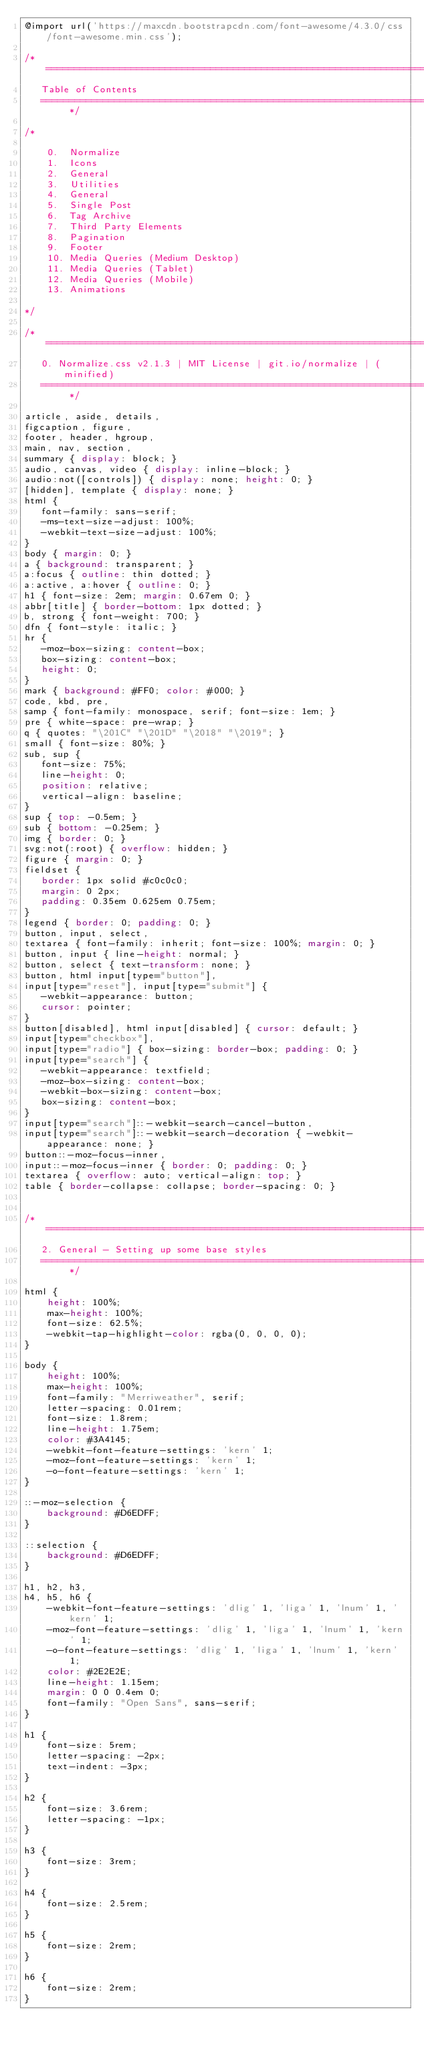<code> <loc_0><loc_0><loc_500><loc_500><_CSS_>@import url('https://maxcdn.bootstrapcdn.com/font-awesome/4.3.0/css/font-awesome.min.css');

/* ==========================================================================
   Table of Contents
   ========================================================================== */

/*

    0.  Normalize
    1.  Icons
    2.  General
    3.  Utilities
    4.  General
    5.  Single Post
    6.  Tag Archive
    7.  Third Party Elements
    8.  Pagination
    9.  Footer
    10. Media Queries (Medium Desktop)
    11. Media Queries (Tablet)
    12. Media Queries (Mobile)
    13. Animations

*/

/* ==========================================================================
   0. Normalize.css v2.1.3 | MIT License | git.io/normalize | (minified)
   ========================================================================== */

article, aside, details,
figcaption, figure,
footer, header, hgroup,
main, nav, section,
summary { display: block; }
audio, canvas, video { display: inline-block; }
audio:not([controls]) { display: none; height: 0; }
[hidden], template { display: none; }
html {
   font-family: sans-serif;
   -ms-text-size-adjust: 100%;
   -webkit-text-size-adjust: 100%;
}
body { margin: 0; }
a { background: transparent; }
a:focus { outline: thin dotted; }
a:active, a:hover { outline: 0; }
h1 { font-size: 2em; margin: 0.67em 0; }
abbr[title] { border-bottom: 1px dotted; }
b, strong { font-weight: 700; }
dfn { font-style: italic; }
hr {
   -moz-box-sizing: content-box;
   box-sizing: content-box;
   height: 0;
}
mark { background: #FF0; color: #000; }
code, kbd, pre,
samp { font-family: monospace, serif; font-size: 1em; }
pre { white-space: pre-wrap; }
q { quotes: "\201C" "\201D" "\2018" "\2019"; }
small { font-size: 80%; }
sub, sup {
   font-size: 75%;
   line-height: 0;
   position: relative;
   vertical-align: baseline;
}
sup { top: -0.5em; }
sub { bottom: -0.25em; }
img { border: 0; }
svg:not(:root) { overflow: hidden; }
figure { margin: 0; }
fieldset {
   border: 1px solid #c0c0c0;
   margin: 0 2px;
   padding: 0.35em 0.625em 0.75em;
}
legend { border: 0; padding: 0; }
button, input, select,
textarea { font-family: inherit; font-size: 100%; margin: 0; }
button, input { line-height: normal; }
button, select { text-transform: none; }
button, html input[type="button"],
input[type="reset"], input[type="submit"] {
   -webkit-appearance: button;
   cursor: pointer;
}
button[disabled], html input[disabled] { cursor: default; }
input[type="checkbox"],
input[type="radio"] { box-sizing: border-box; padding: 0; }
input[type="search"] {
   -webkit-appearance: textfield;
   -moz-box-sizing: content-box;
   -webkit-box-sizing: content-box;
   box-sizing: content-box;
}
input[type="search"]::-webkit-search-cancel-button,
input[type="search"]::-webkit-search-decoration { -webkit-appearance: none; }
button::-moz-focus-inner,
input::-moz-focus-inner { border: 0; padding: 0; }
textarea { overflow: auto; vertical-align: top; }
table { border-collapse: collapse; border-spacing: 0; }


/* ==========================================================================
   2. General - Setting up some base styles
   ========================================================================== */

html {
    height: 100%;
    max-height: 100%;
    font-size: 62.5%;
    -webkit-tap-highlight-color: rgba(0, 0, 0, 0);
}

body {
    height: 100%;
    max-height: 100%;
    font-family: "Merriweather", serif;
    letter-spacing: 0.01rem;
    font-size: 1.8rem;
    line-height: 1.75em;
    color: #3A4145;
    -webkit-font-feature-settings: 'kern' 1;
    -moz-font-feature-settings: 'kern' 1;
    -o-font-feature-settings: 'kern' 1;
}

::-moz-selection {
    background: #D6EDFF;
}

::selection {
    background: #D6EDFF;
}

h1, h2, h3,
h4, h5, h6 {
    -webkit-font-feature-settings: 'dlig' 1, 'liga' 1, 'lnum' 1, 'kern' 1;
    -moz-font-feature-settings: 'dlig' 1, 'liga' 1, 'lnum' 1, 'kern' 1;
    -o-font-feature-settings: 'dlig' 1, 'liga' 1, 'lnum' 1, 'kern' 1;
    color: #2E2E2E;
    line-height: 1.15em;
    margin: 0 0 0.4em 0;
    font-family: "Open Sans", sans-serif;
}

h1 {
    font-size: 5rem;
    letter-spacing: -2px;
    text-indent: -3px;
}

h2 {
    font-size: 3.6rem;
    letter-spacing: -1px;
}

h3 {
    font-size: 3rem;
}

h4 {
    font-size: 2.5rem;
}

h5 {
    font-size: 2rem;
}

h6 {
    font-size: 2rem;
}
</code> 